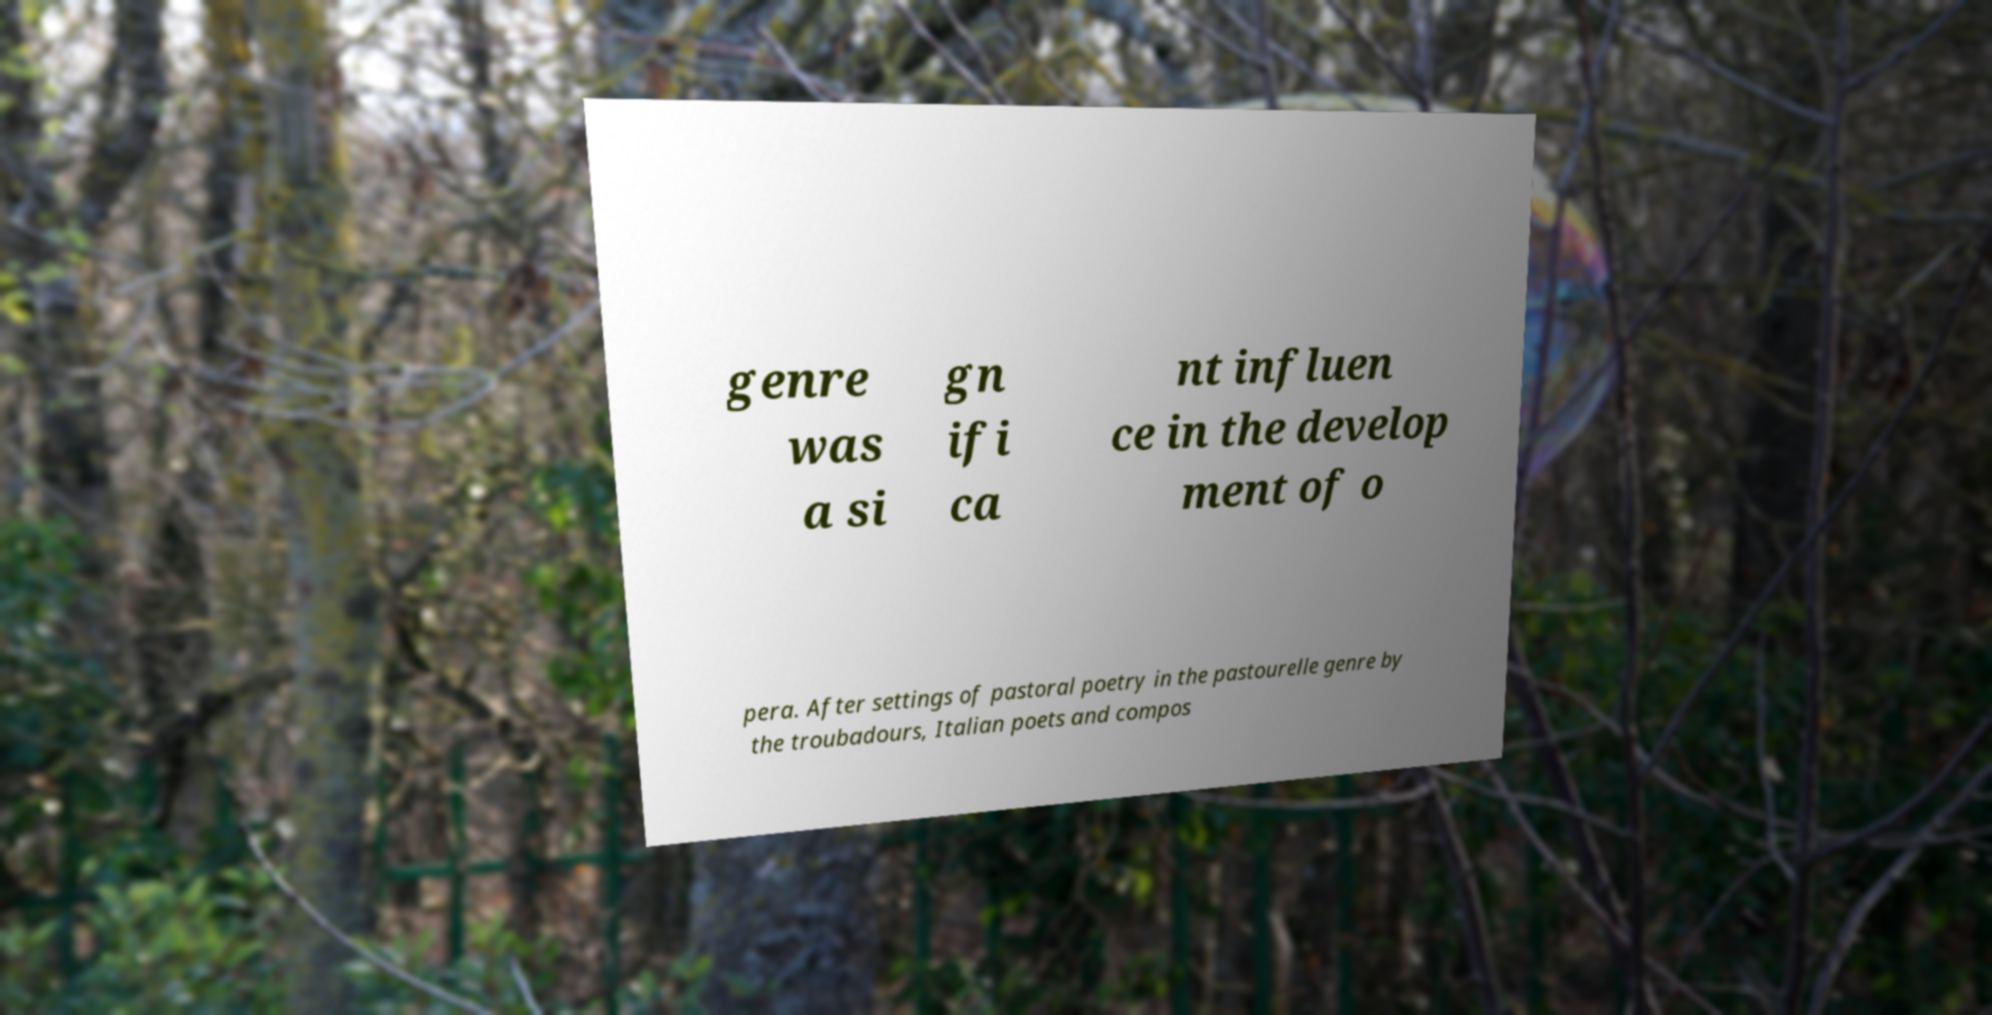Can you accurately transcribe the text from the provided image for me? genre was a si gn ifi ca nt influen ce in the develop ment of o pera. After settings of pastoral poetry in the pastourelle genre by the troubadours, Italian poets and compos 